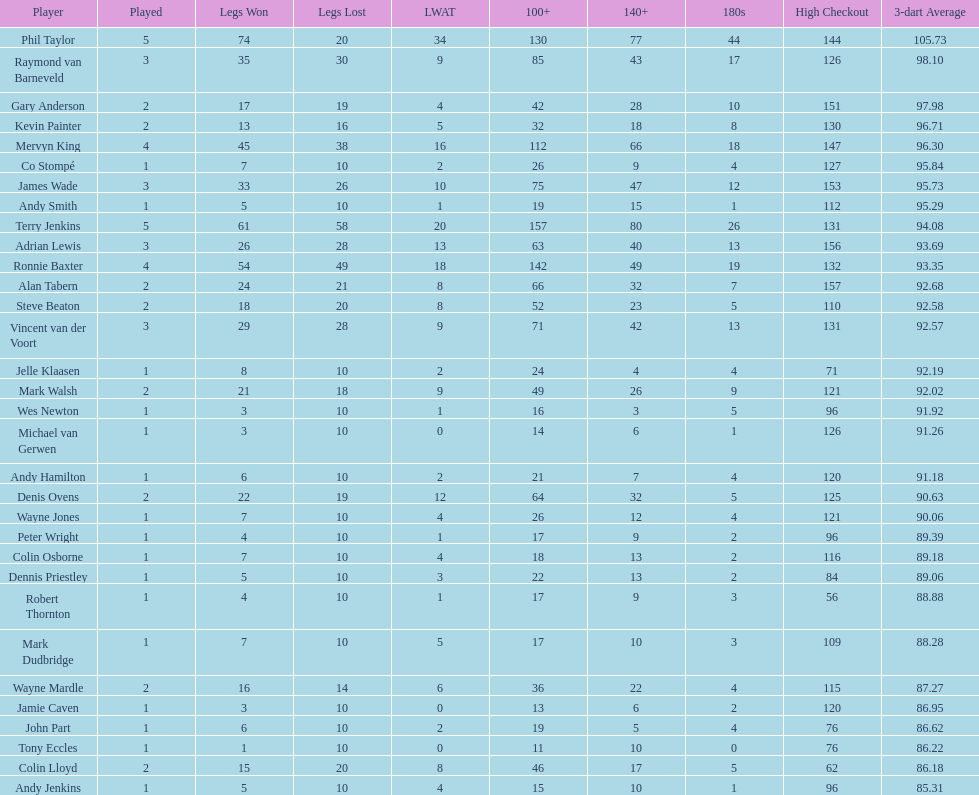What is the quantity of legs james wade has lost? 26. 